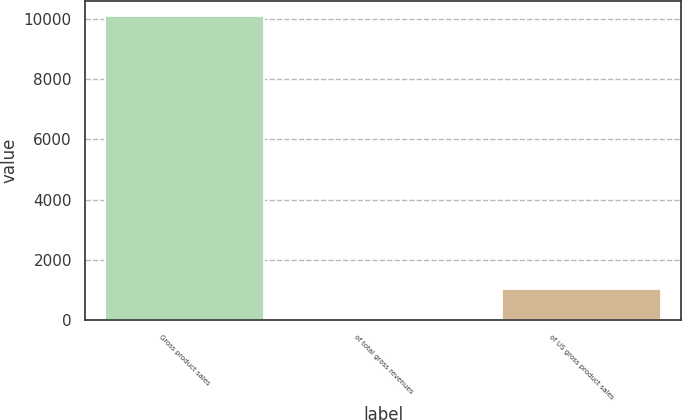<chart> <loc_0><loc_0><loc_500><loc_500><bar_chart><fcel>Gross product sales<fcel>of total gross revenues<fcel>of US gross product sales<nl><fcel>10100<fcel>31<fcel>1037.9<nl></chart> 